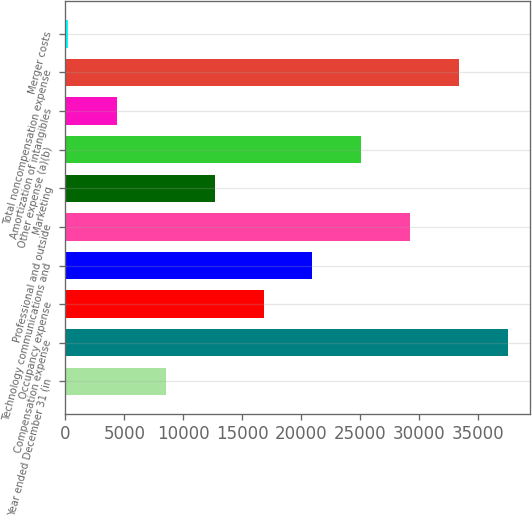<chart> <loc_0><loc_0><loc_500><loc_500><bar_chart><fcel>Year ended December 31 (in<fcel>Compensation expense<fcel>Occupancy expense<fcel>Technology communications and<fcel>Professional and outside<fcel>Marketing<fcel>Other expense (a)(b)<fcel>Amortization of intangibles<fcel>Total noncompensation expense<fcel>Merger costs<nl><fcel>8507.8<fcel>37553.6<fcel>16806.6<fcel>20956<fcel>29254.8<fcel>12657.2<fcel>25105.4<fcel>4358.4<fcel>33404.2<fcel>209<nl></chart> 